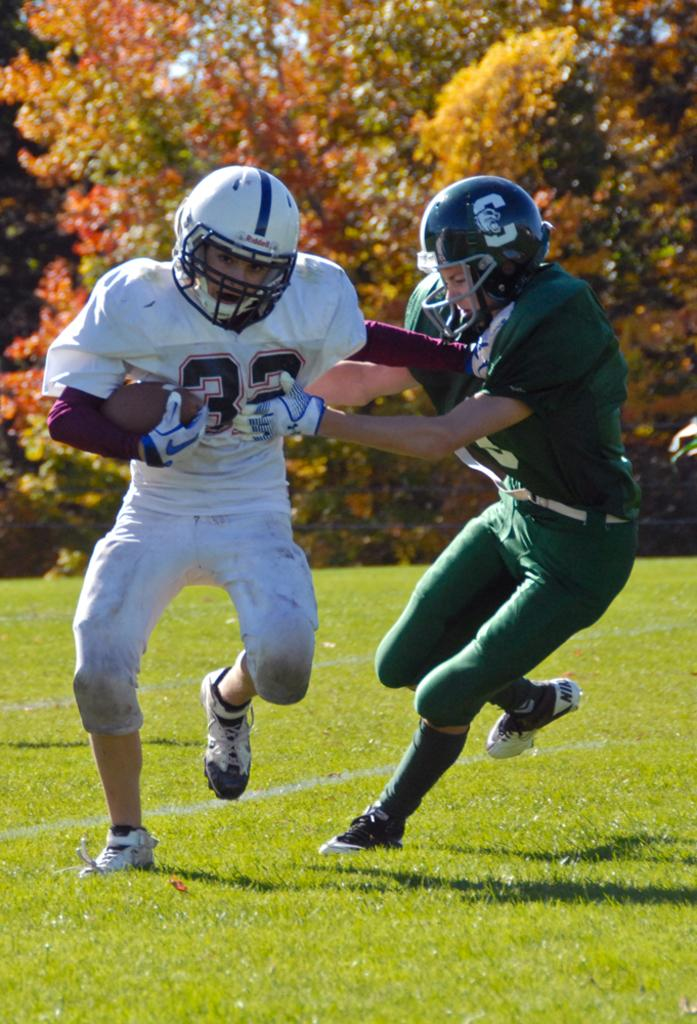How many people are in the image? There are two persons in the image. What are the persons wearing on their heads? Both persons are wearing helmets. What are the persons wearing on their hands? Both persons are wearing gloves. What is one person holding in the image? One person is holding a ball. What type of surface is visible on the ground in the image? There is grass on the ground in the image. What can be seen in the background of the image? There are trees in the background of the image. What type of truck can be seen in the image? There is no truck present in the image. How many feet does the mom have in the image? There is no mom present in the image, so it is not possible to determine the number of feet. 